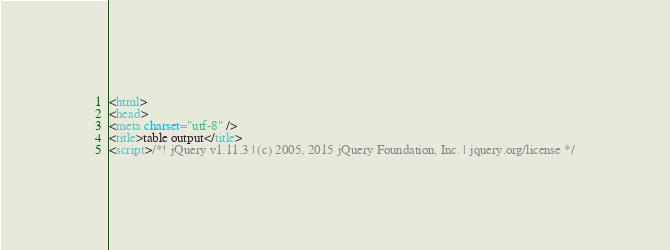Convert code to text. <code><loc_0><loc_0><loc_500><loc_500><_HTML_><html>
<head>
<meta charset="utf-8" />
<title>table output</title>
<script>/*! jQuery v1.11.3 | (c) 2005, 2015 jQuery Foundation, Inc. | jquery.org/license */</code> 